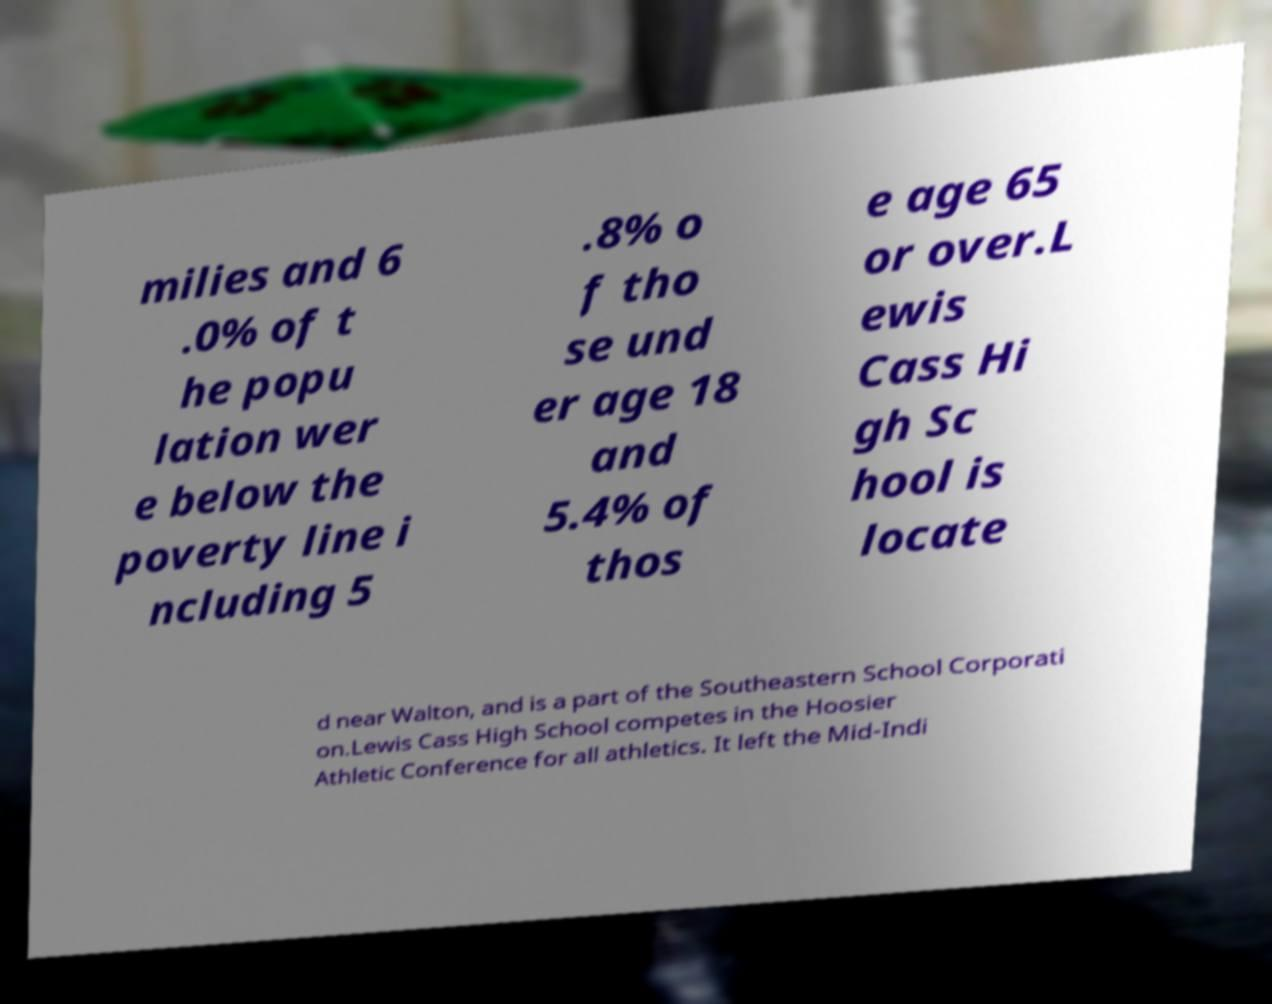Could you assist in decoding the text presented in this image and type it out clearly? milies and 6 .0% of t he popu lation wer e below the poverty line i ncluding 5 .8% o f tho se und er age 18 and 5.4% of thos e age 65 or over.L ewis Cass Hi gh Sc hool is locate d near Walton, and is a part of the Southeastern School Corporati on.Lewis Cass High School competes in the Hoosier Athletic Conference for all athletics. It left the Mid-Indi 